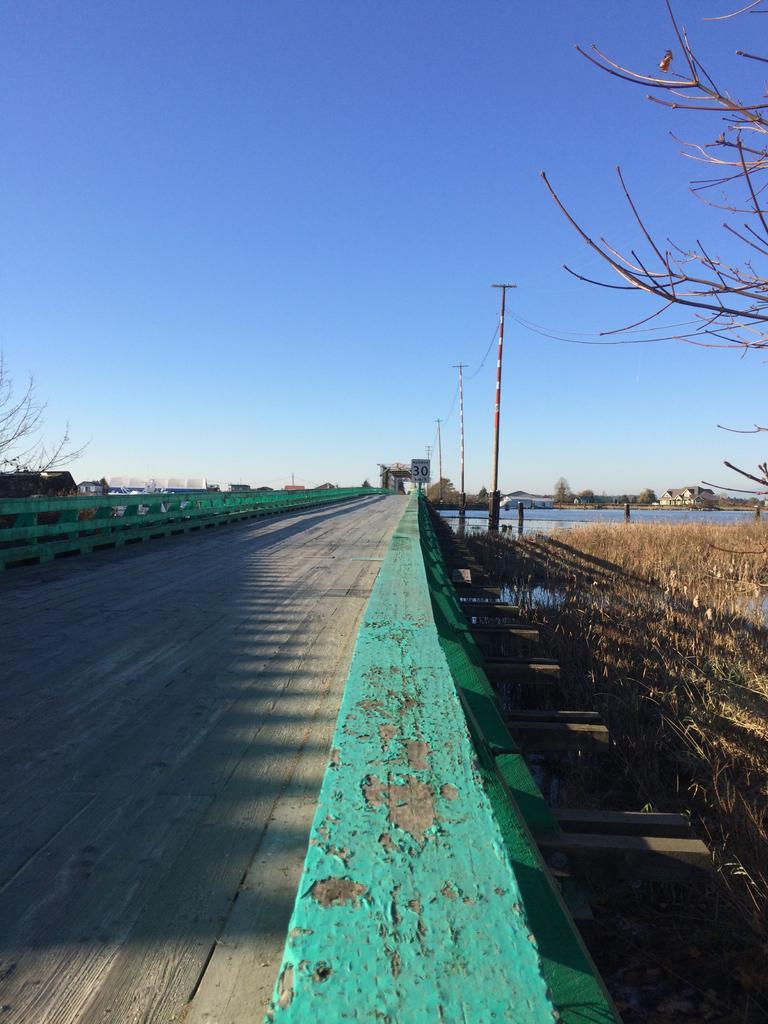How would you summarize this image in a sentence or two? On the left there is a bridge. On the right there is grass and a tree. In the background there are poles, water and sky. 